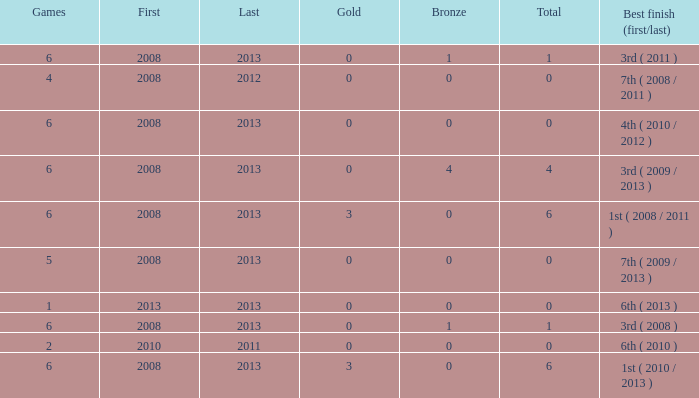What is the latest first year with 0 total medals and over 0 golds? 2008.0. 